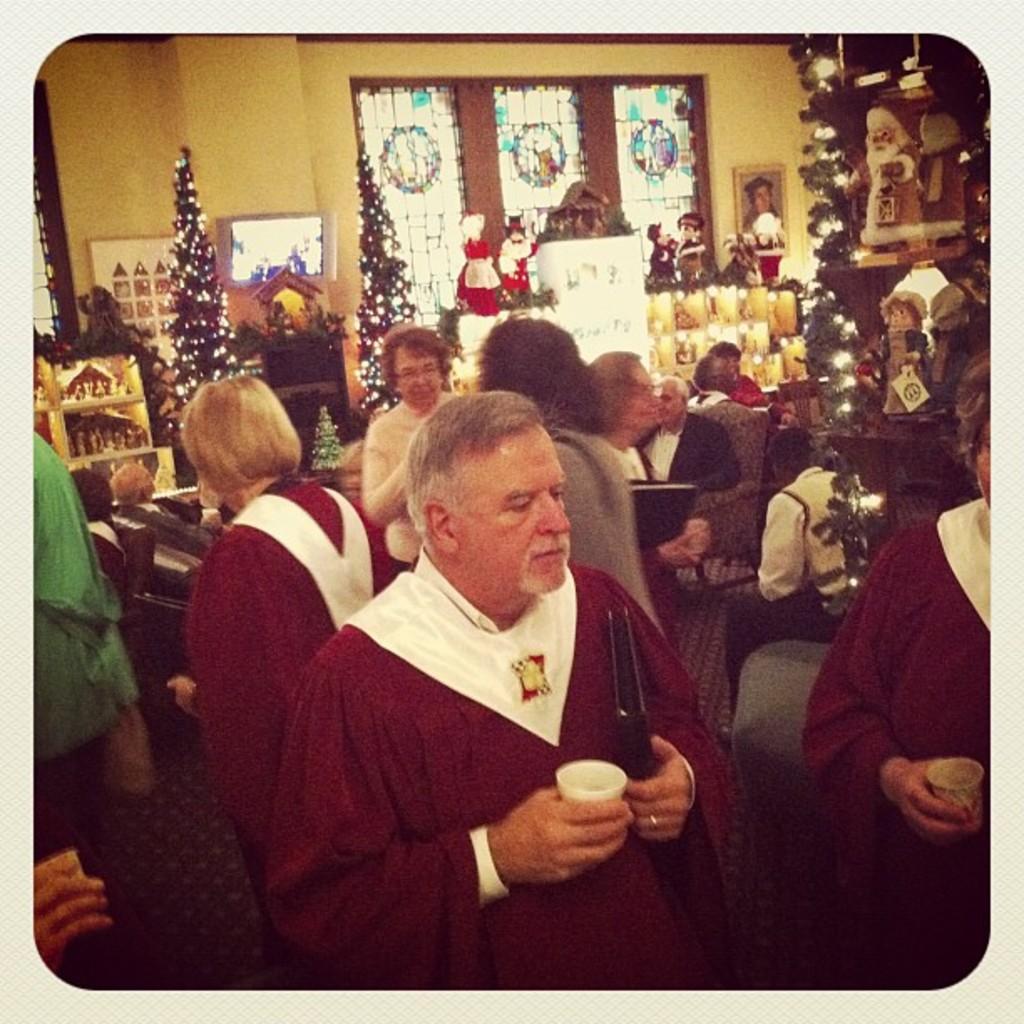Could you give a brief overview of what you see in this image? In the picture we can see some people are standing and holding a glasses and one man is also holding a book they are in costumes and behind them also we can see some people are standing and talking to each other and behind it we can see some Christmas trees which are decorated with lights and beside it we can see some dolls on the desk and behind it we can see a wall with a with windows and glasses to it and beside it we can see a photo frame with a image. 